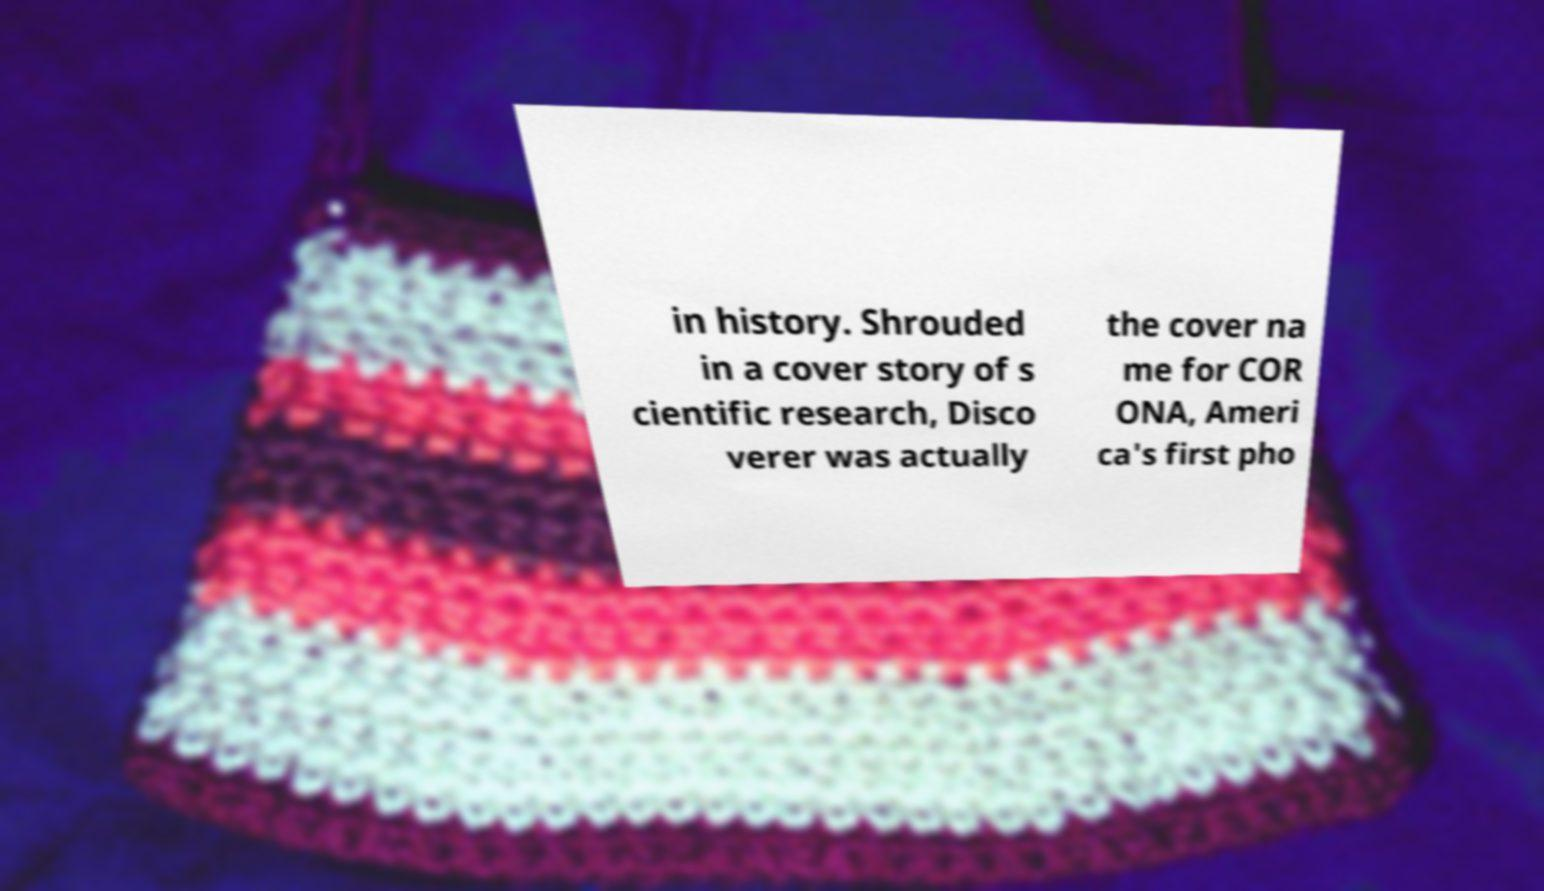What messages or text are displayed in this image? I need them in a readable, typed format. in history. Shrouded in a cover story of s cientific research, Disco verer was actually the cover na me for COR ONA, Ameri ca's first pho 